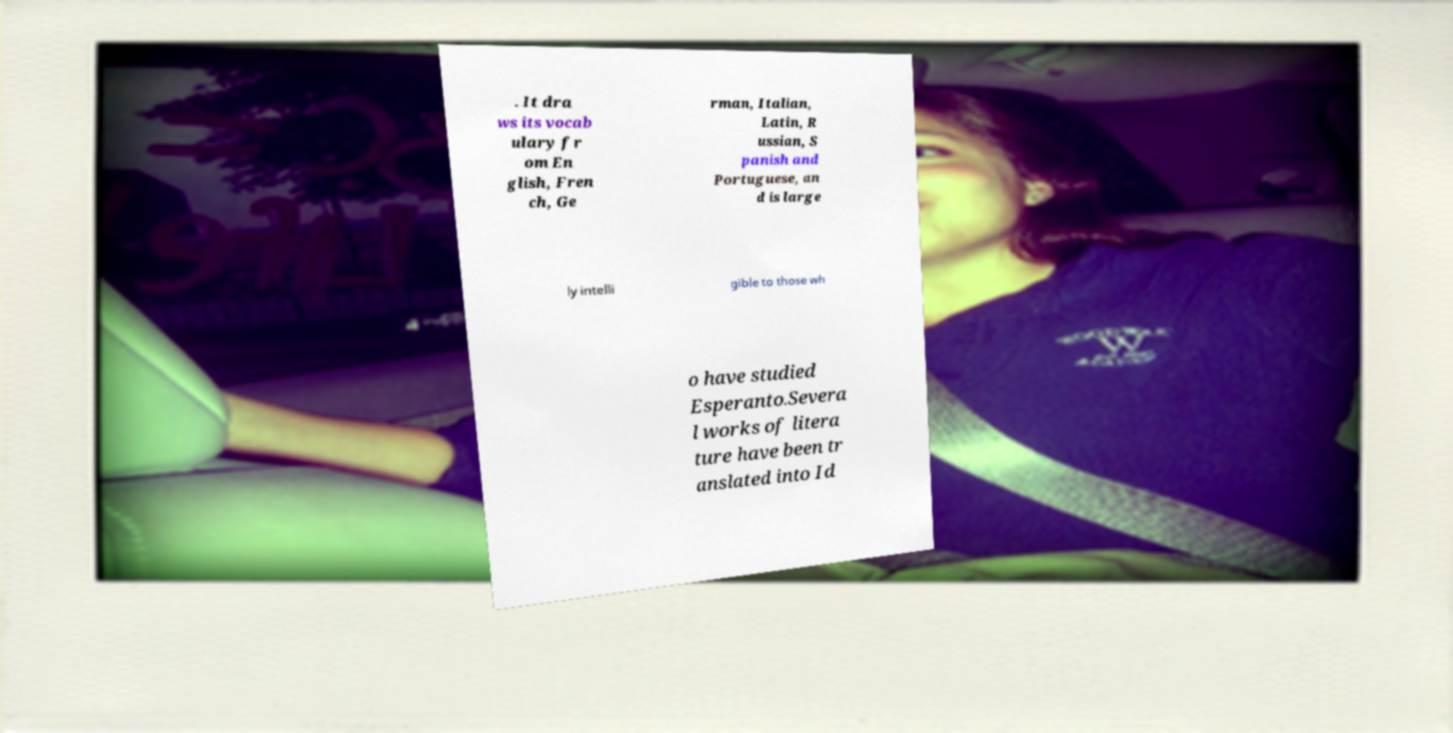Can you accurately transcribe the text from the provided image for me? . It dra ws its vocab ulary fr om En glish, Fren ch, Ge rman, Italian, Latin, R ussian, S panish and Portuguese, an d is large ly intelli gible to those wh o have studied Esperanto.Severa l works of litera ture have been tr anslated into Id 